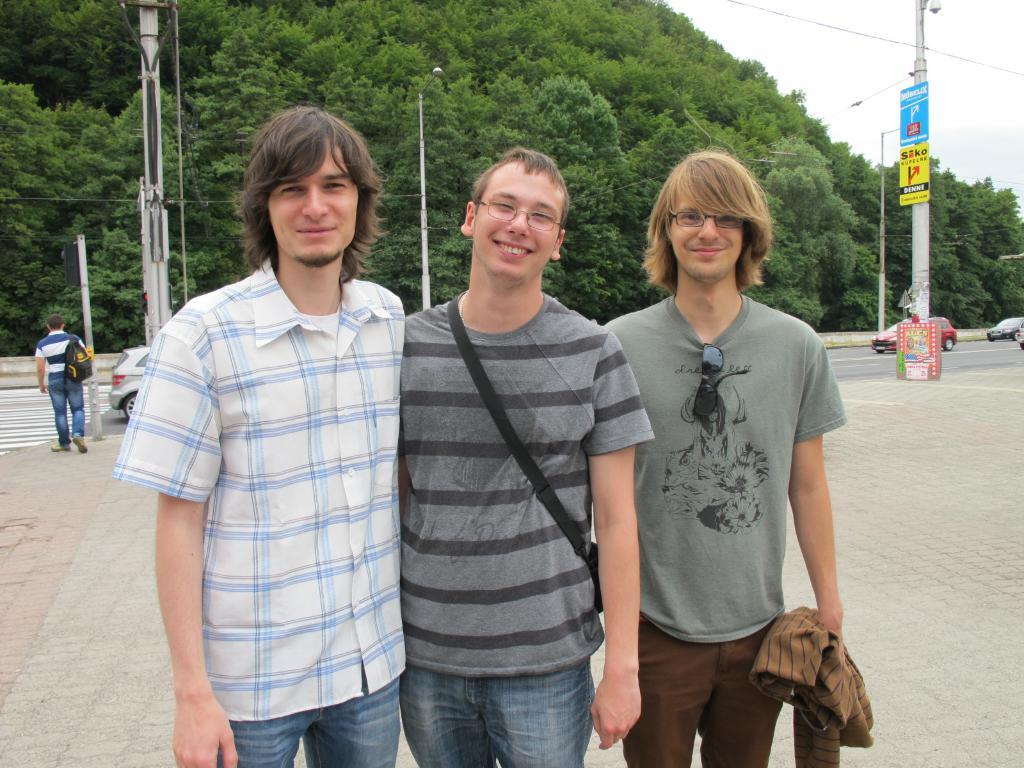How many people are standing in the image? There are three persons standing in the image. What can be seen in the background of the image? There are vehicles, trees, and two poles in the background. How many fingers does the giant have in the image? There are no giants present in the image, so it is not possible to determine the number of fingers they might have. 